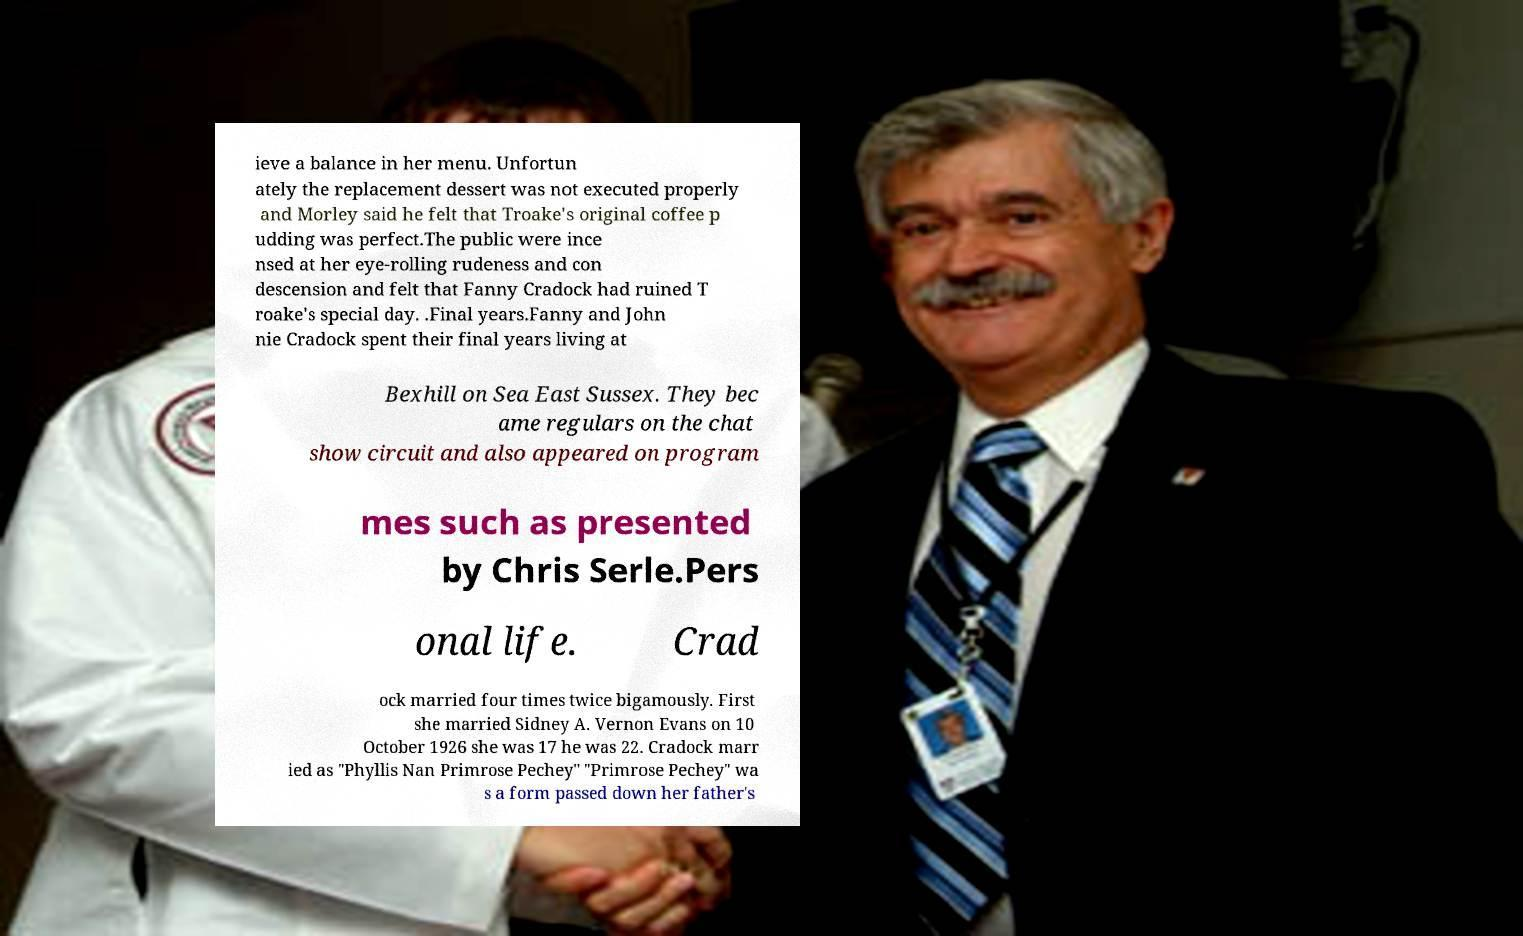Could you extract and type out the text from this image? ieve a balance in her menu. Unfortun ately the replacement dessert was not executed properly and Morley said he felt that Troake's original coffee p udding was perfect.The public were ince nsed at her eye-rolling rudeness and con descension and felt that Fanny Cradock had ruined T roake's special day. .Final years.Fanny and John nie Cradock spent their final years living at Bexhill on Sea East Sussex. They bec ame regulars on the chat show circuit and also appeared on program mes such as presented by Chris Serle.Pers onal life. Crad ock married four times twice bigamously. First she married Sidney A. Vernon Evans on 10 October 1926 she was 17 he was 22. Cradock marr ied as "Phyllis Nan Primrose Pechey" "Primrose Pechey" wa s a form passed down her father's 